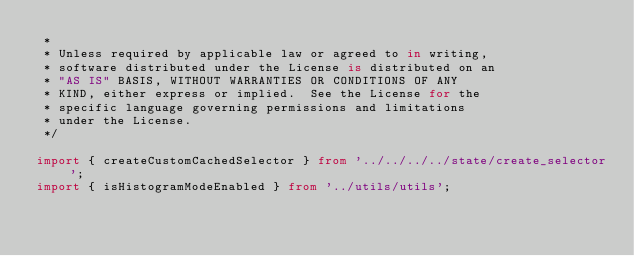<code> <loc_0><loc_0><loc_500><loc_500><_TypeScript_> *
 * Unless required by applicable law or agreed to in writing,
 * software distributed under the License is distributed on an
 * "AS IS" BASIS, WITHOUT WARRANTIES OR CONDITIONS OF ANY
 * KIND, either express or implied.  See the License for the
 * specific language governing permissions and limitations
 * under the License.
 */

import { createCustomCachedSelector } from '../../../../state/create_selector';
import { isHistogramModeEnabled } from '../utils/utils';</code> 